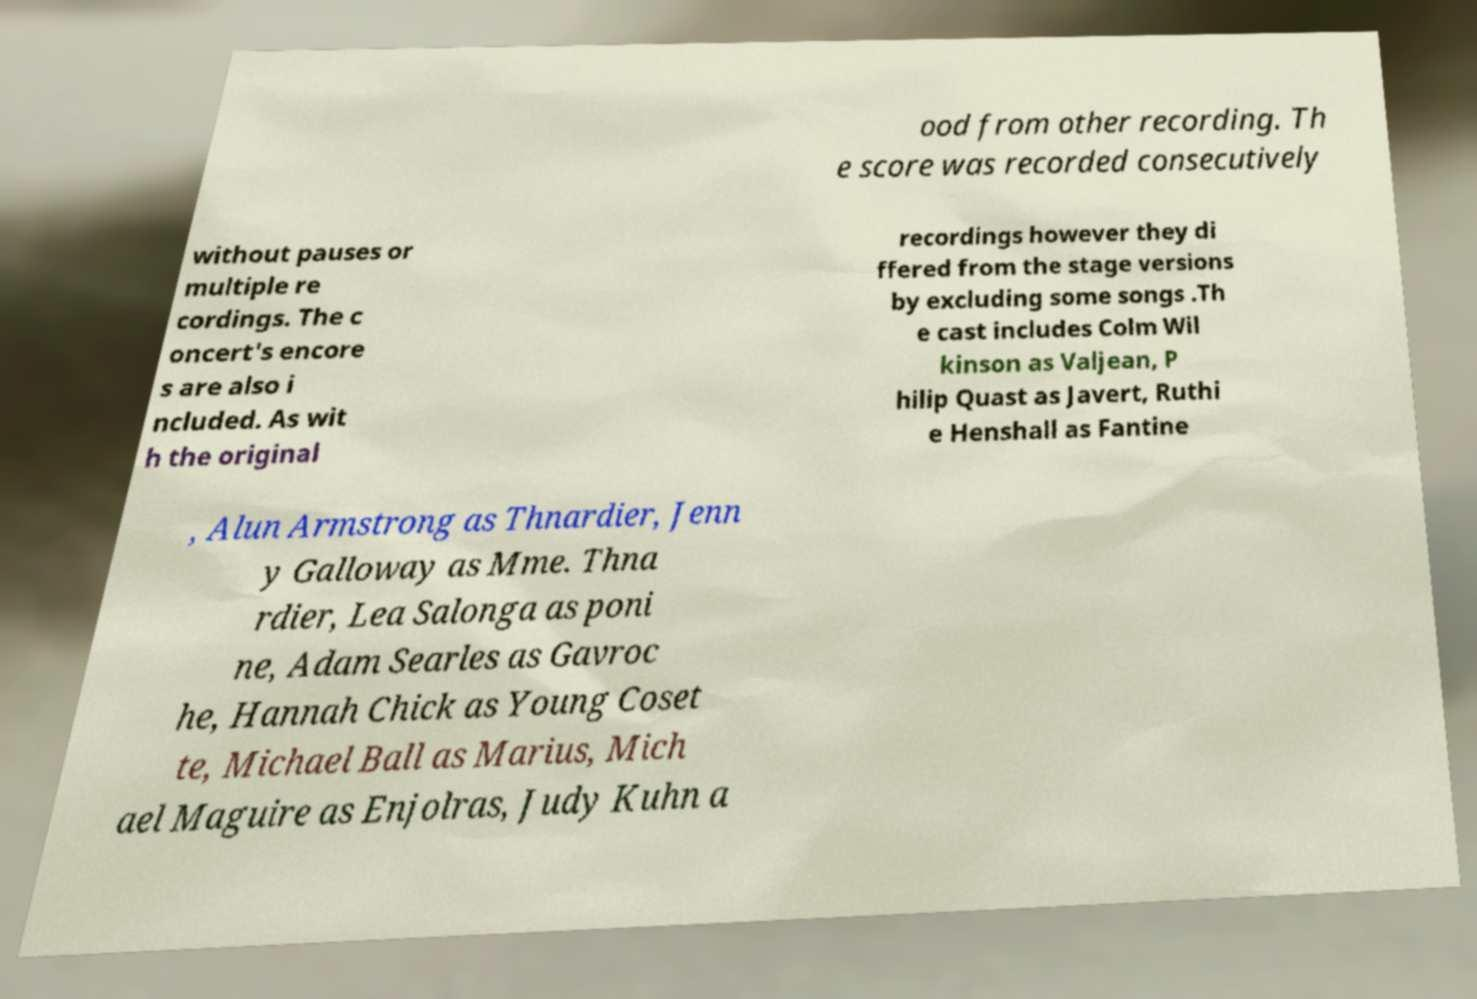Please identify and transcribe the text found in this image. ood from other recording. Th e score was recorded consecutively without pauses or multiple re cordings. The c oncert's encore s are also i ncluded. As wit h the original recordings however they di ffered from the stage versions by excluding some songs .Th e cast includes Colm Wil kinson as Valjean, P hilip Quast as Javert, Ruthi e Henshall as Fantine , Alun Armstrong as Thnardier, Jenn y Galloway as Mme. Thna rdier, Lea Salonga as poni ne, Adam Searles as Gavroc he, Hannah Chick as Young Coset te, Michael Ball as Marius, Mich ael Maguire as Enjolras, Judy Kuhn a 